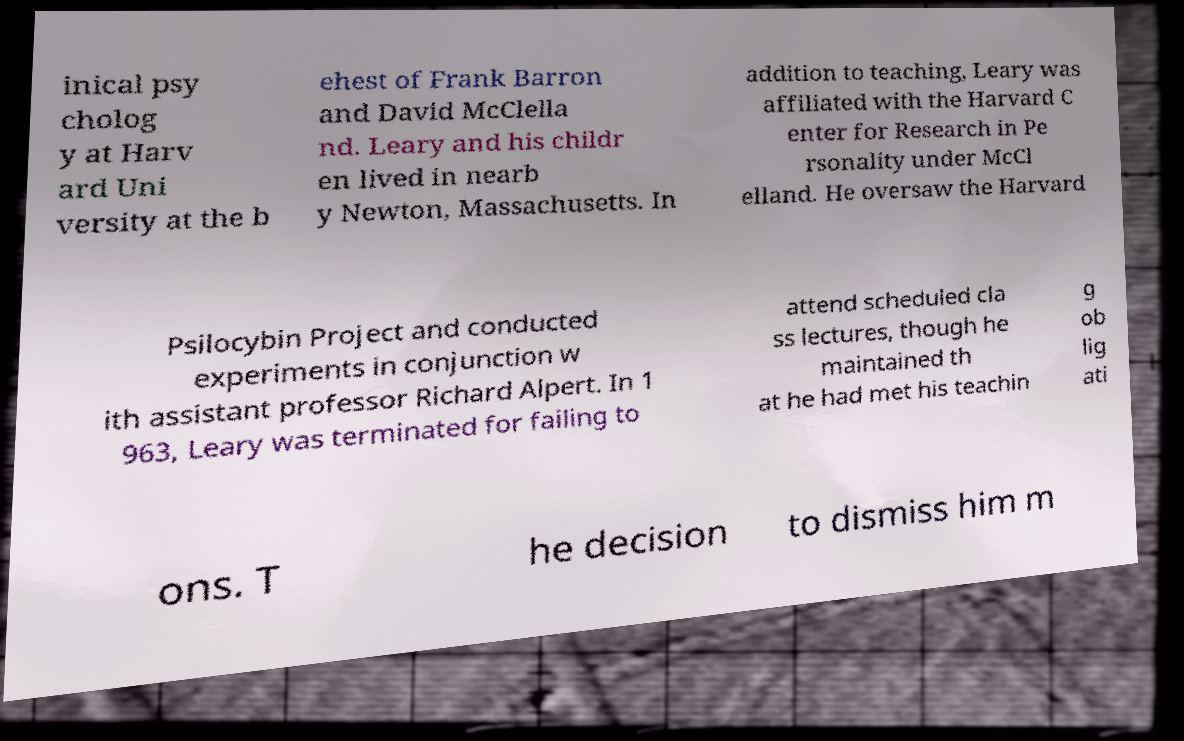For documentation purposes, I need the text within this image transcribed. Could you provide that? inical psy cholog y at Harv ard Uni versity at the b ehest of Frank Barron and David McClella nd. Leary and his childr en lived in nearb y Newton, Massachusetts. In addition to teaching, Leary was affiliated with the Harvard C enter for Research in Pe rsonality under McCl elland. He oversaw the Harvard Psilocybin Project and conducted experiments in conjunction w ith assistant professor Richard Alpert. In 1 963, Leary was terminated for failing to attend scheduled cla ss lectures, though he maintained th at he had met his teachin g ob lig ati ons. T he decision to dismiss him m 